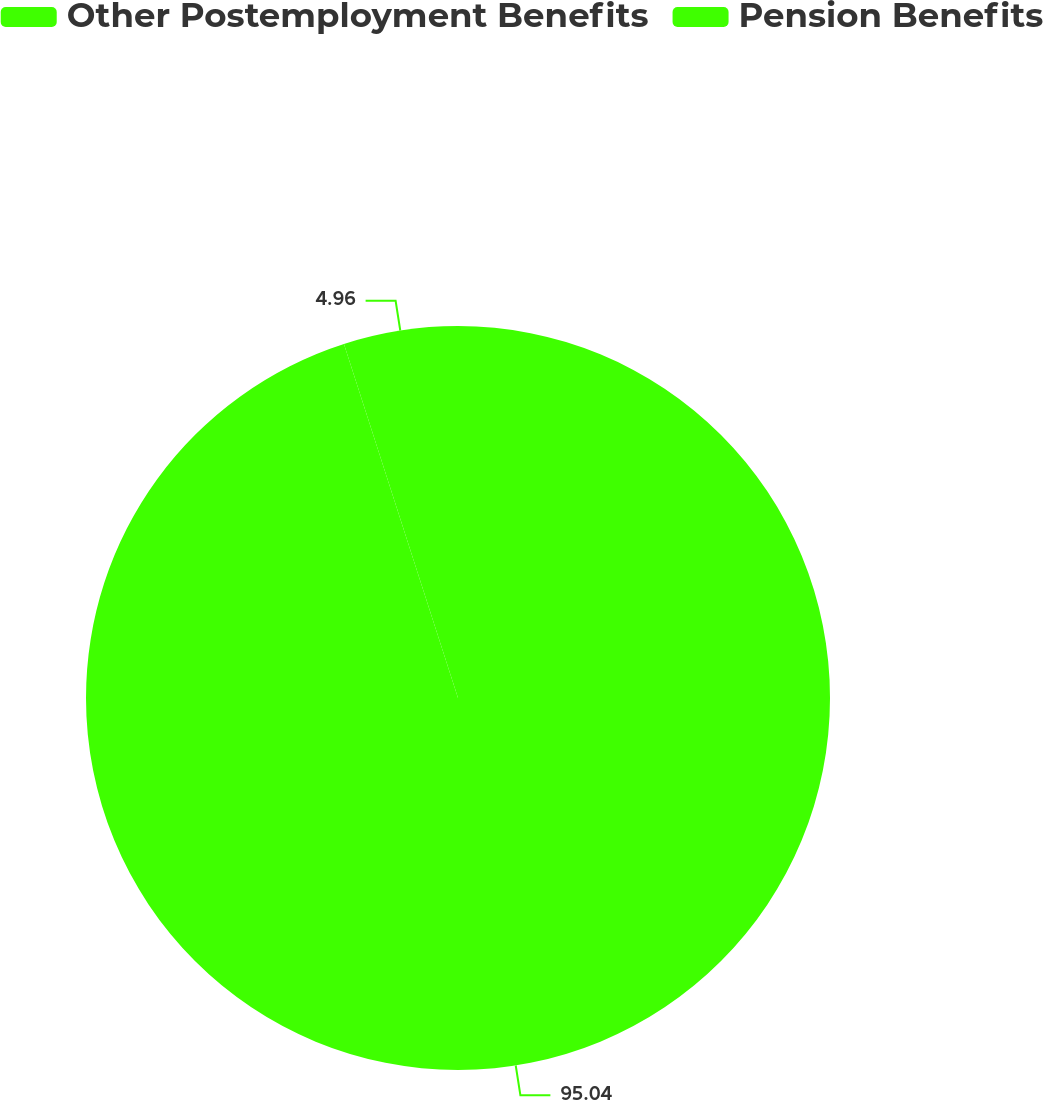Convert chart to OTSL. <chart><loc_0><loc_0><loc_500><loc_500><pie_chart><fcel>Other Postemployment Benefits<fcel>Pension Benefits<nl><fcel>95.04%<fcel>4.96%<nl></chart> 